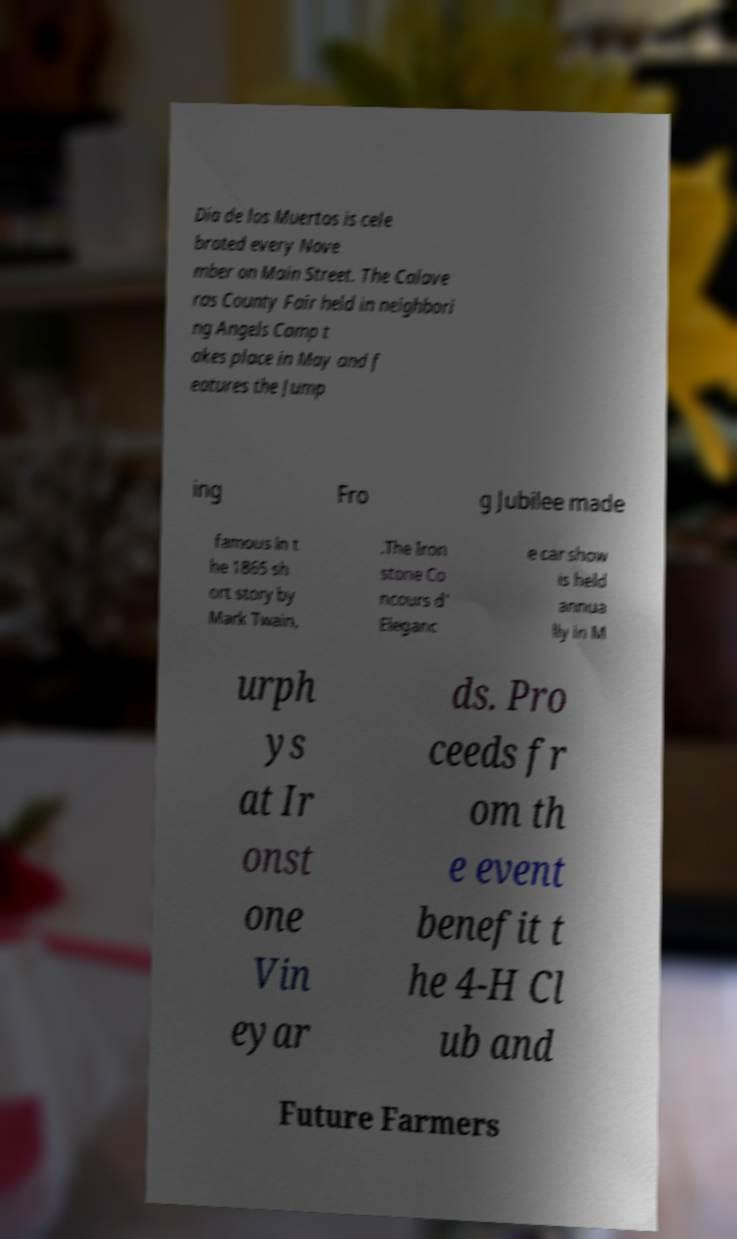There's text embedded in this image that I need extracted. Can you transcribe it verbatim? Dia de los Muertos is cele brated every Nove mber on Main Street. The Calave ras County Fair held in neighbori ng Angels Camp t akes place in May and f eatures the Jump ing Fro g Jubilee made famous in t he 1865 sh ort story by Mark Twain, .The Iron stone Co ncours d' Eleganc e car show is held annua lly in M urph ys at Ir onst one Vin eyar ds. Pro ceeds fr om th e event benefit t he 4-H Cl ub and Future Farmers 